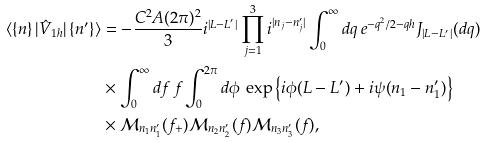Convert formula to latex. <formula><loc_0><loc_0><loc_500><loc_500>\langle \left \{ n \right \} | \hat { V } _ { 1 h } | \left \{ n ^ { \prime } \right \} \rangle & = - \frac { C ^ { 2 } A ( 2 \pi ) ^ { 2 } } { 3 } i ^ { | L - L ^ { \prime } | } \prod _ { j = 1 } ^ { 3 } i ^ { | n _ { j } - n ^ { \prime } _ { j } | } \int _ { 0 } ^ { \infty } d q \, e ^ { - q ^ { 2 } / 2 - q h } J _ { | L - L ^ { \prime } | } ( d q ) \\ & \times \int _ { 0 } ^ { \infty } d f \, f \int _ { 0 } ^ { 2 \pi } d \phi \, \exp \left \{ i \phi ( L - L ^ { \prime } ) + i \psi ( n _ { 1 } - n _ { 1 } ^ { \prime } ) \right \} \\ & \times \mathcal { M } _ { n _ { 1 } n ^ { \prime } _ { 1 } } ( f _ { + } ) \mathcal { M } _ { n _ { 2 } n ^ { \prime } _ { 2 } } ( f ) \mathcal { M } _ { n _ { 3 } n ^ { \prime } _ { 3 } } ( f ) ,</formula> 